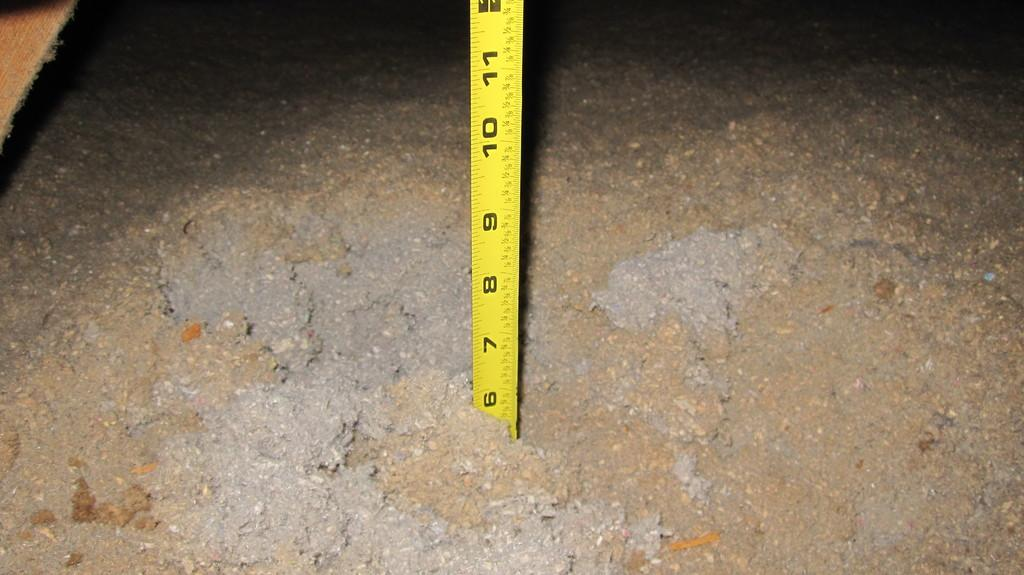<image>
Describe the image concisely. A tape measure is stuck in wet concrete at the six inch mark. 